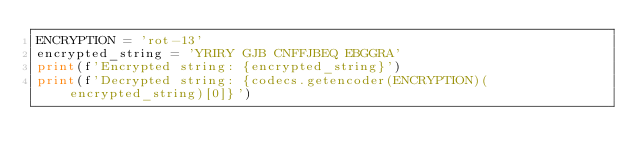Convert code to text. <code><loc_0><loc_0><loc_500><loc_500><_Python_>ENCRYPTION = 'rot-13'
encrypted_string = 'YRIRY GJB CNFFJBEQ EBGGRA'
print(f'Encrypted string: {encrypted_string}')
print(f'Decrypted string: {codecs.getencoder(ENCRYPTION)(encrypted_string)[0]}')</code> 